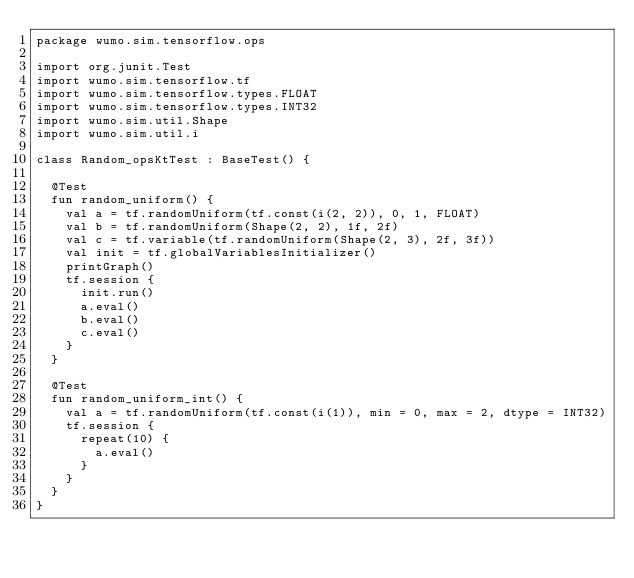<code> <loc_0><loc_0><loc_500><loc_500><_Kotlin_>package wumo.sim.tensorflow.ops

import org.junit.Test
import wumo.sim.tensorflow.tf
import wumo.sim.tensorflow.types.FLOAT
import wumo.sim.tensorflow.types.INT32
import wumo.sim.util.Shape
import wumo.sim.util.i

class Random_opsKtTest : BaseTest() {
  
  @Test
  fun random_uniform() {
    val a = tf.randomUniform(tf.const(i(2, 2)), 0, 1, FLOAT)
    val b = tf.randomUniform(Shape(2, 2), 1f, 2f)
    val c = tf.variable(tf.randomUniform(Shape(2, 3), 2f, 3f))
    val init = tf.globalVariablesInitializer()
    printGraph()
    tf.session {
      init.run()
      a.eval()
      b.eval()
      c.eval()
    }
  }
  
  @Test
  fun random_uniform_int() {
    val a = tf.randomUniform(tf.const(i(1)), min = 0, max = 2, dtype = INT32)
    tf.session {
      repeat(10) {
        a.eval()
      }
    }
  }
}</code> 